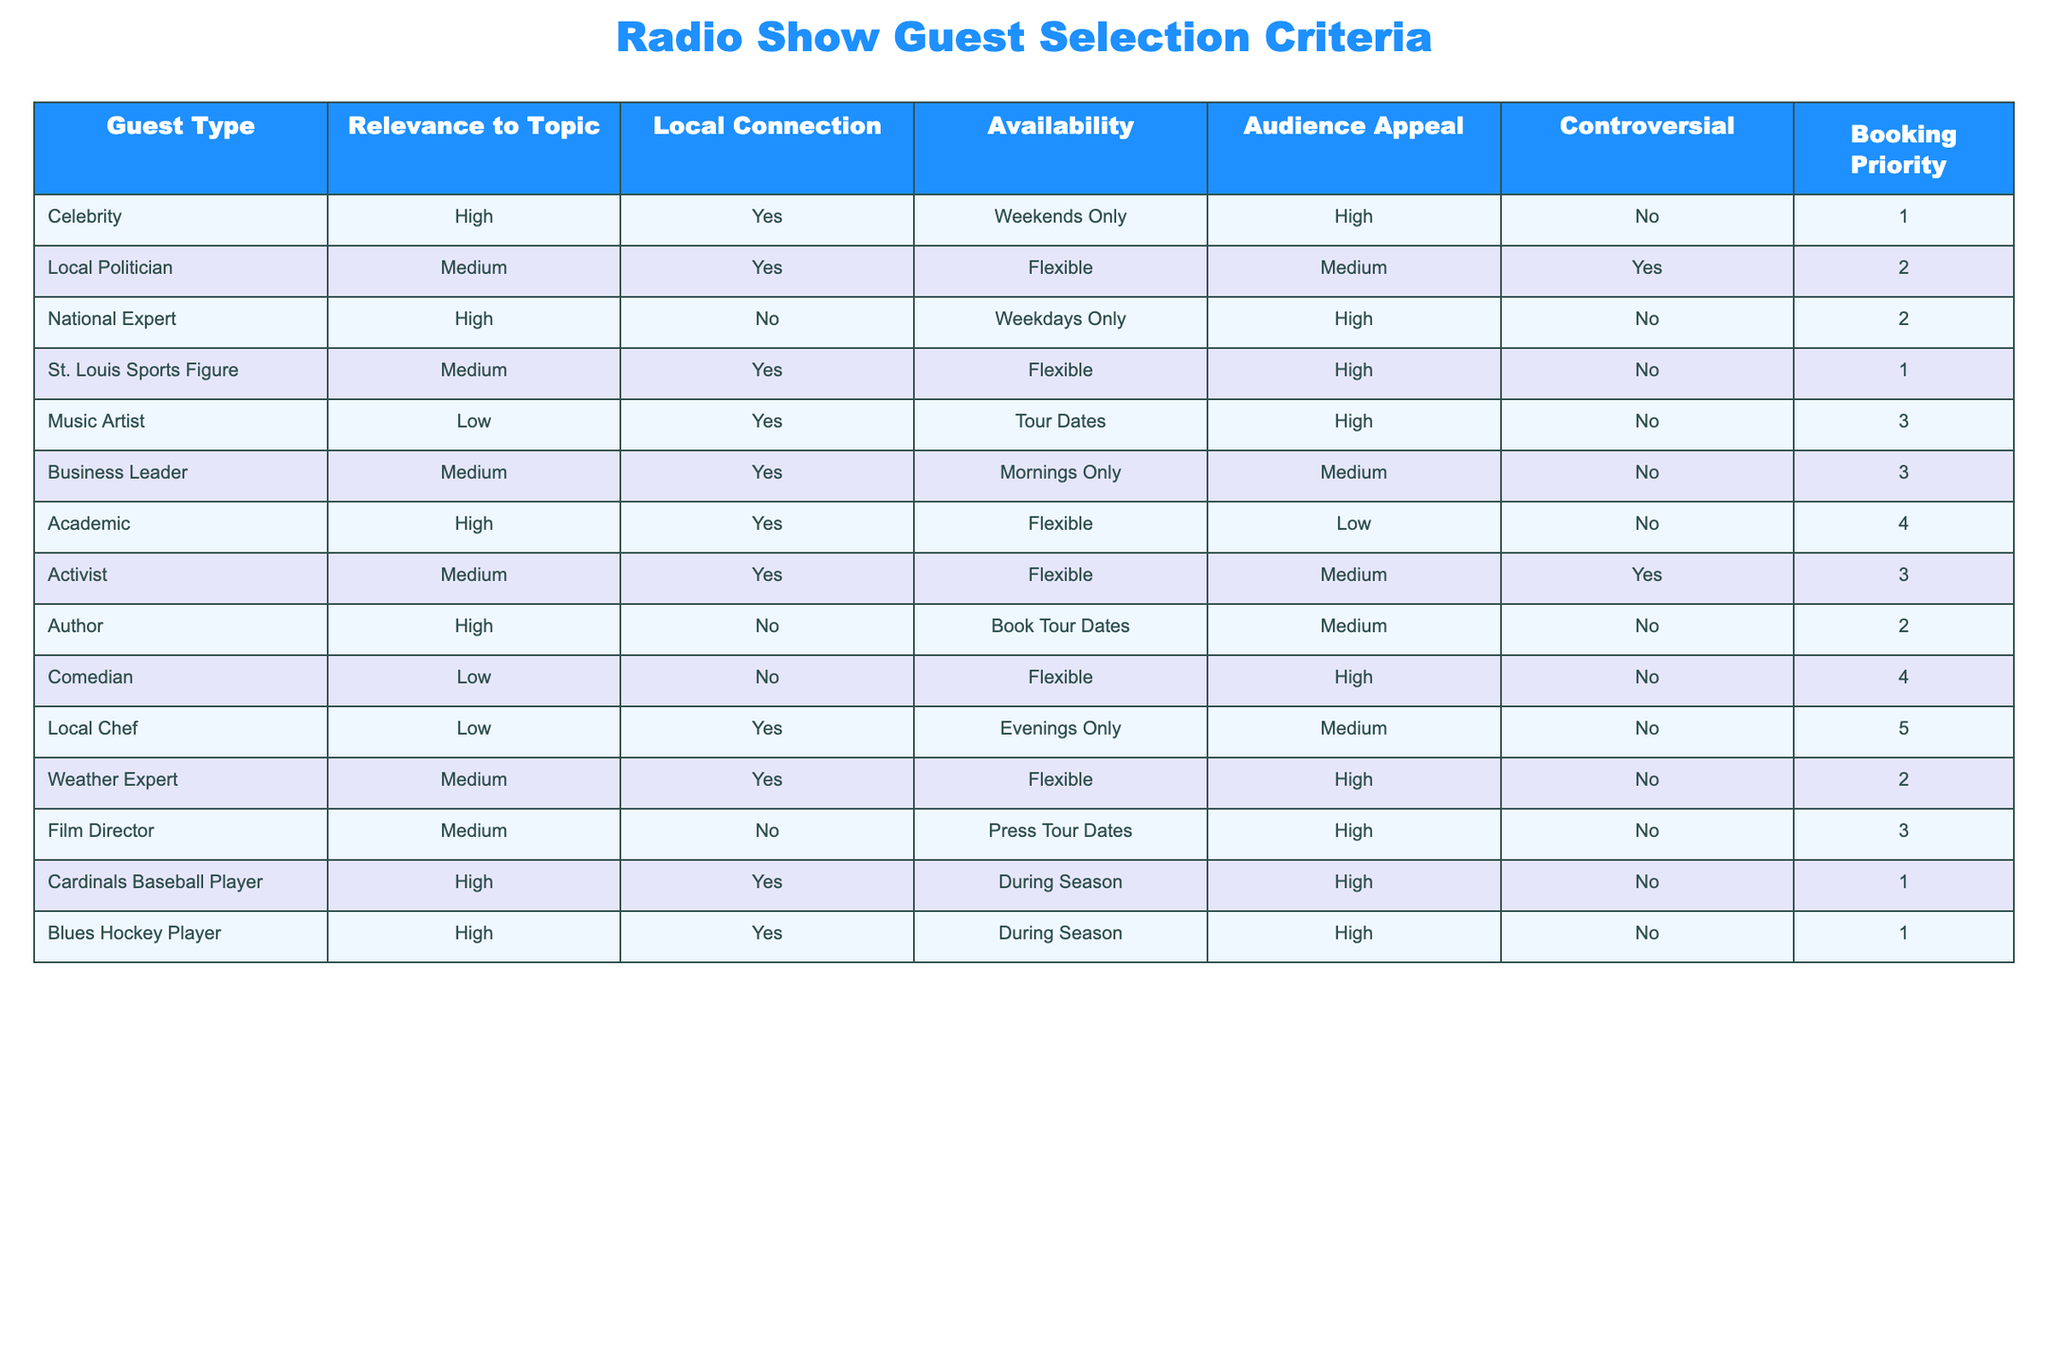What is the booking priority of a Celebrity guest? The table shows that the booking priority assigned to a Celebrity is 1.
Answer: 1 Which guest types have a local connection? By examining the "Local Connection" column, the guest types that have a local connection (marked as "Yes") are Celebrity, Local Politician, St. Louis Sports Figure, Music Artist, Business Leader, Academic, Activist, Local Chef, Weather Expert, and Cardinals Baseball Player and Blues Hockey Player.
Answer: 11 Are there any guests who are both controversial and have high audience appeal? Looking at the "Controversial" column and the "Audience Appeal" column, none of the guests are marked as both controversial ("Yes") and have high audience appeal.
Answer: No What is the average booking priority of guests available on weekdays only? The guests available on weekdays only are the National Expert. The booking priority for this guest is 2. Hence, the average booking priority is 2.
Answer: 2 Which guest type has the highest audience appeal but the lowest relevance to the topic? The "Music Artist" has high audience appeal but is listed as having low relevance to the topic.
Answer: Music Artist What is the total number of guests categorized as "Medium" relevance? The table identifies five guests with medium relevance. They are the Local Politician, St. Louis Sports Figure, Business Leader, Activist, and Weather Expert.
Answer: 5 Which guest types can appear on weekends only? A Celebrity is the only guest type that can appear on weekends only, as indicated in the "Availability" column.
Answer: Celebrity Which guest has the highest relevance with a local connection and flexible availability? The Academic guest type has high relevance to the topic, a local connection, and flexible availability.
Answer: Academic Are there any guests who are both a Sports Figure and have high audience appeal? Yes, the Cardinals Baseball Player and the Blues Hockey Player both fall in the Sports Figure category and have high audience appeal.
Answer: Yes 